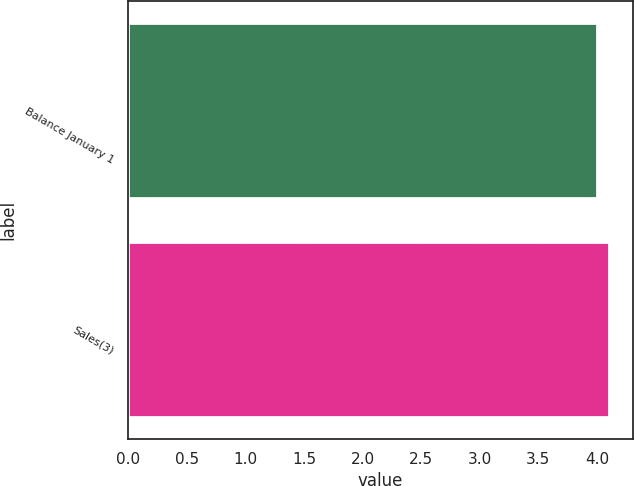Convert chart. <chart><loc_0><loc_0><loc_500><loc_500><bar_chart><fcel>Balance January 1<fcel>Sales(3)<nl><fcel>4<fcel>4.1<nl></chart> 